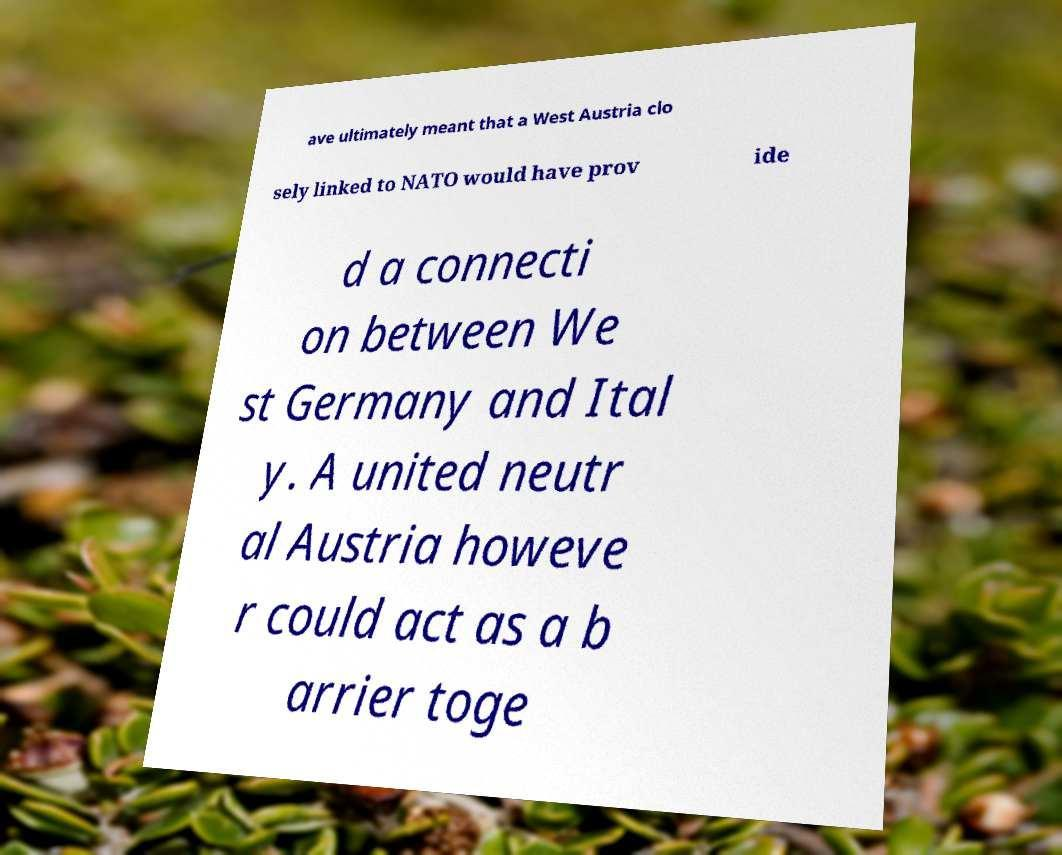There's text embedded in this image that I need extracted. Can you transcribe it verbatim? ave ultimately meant that a West Austria clo sely linked to NATO would have prov ide d a connecti on between We st Germany and Ital y. A united neutr al Austria howeve r could act as a b arrier toge 